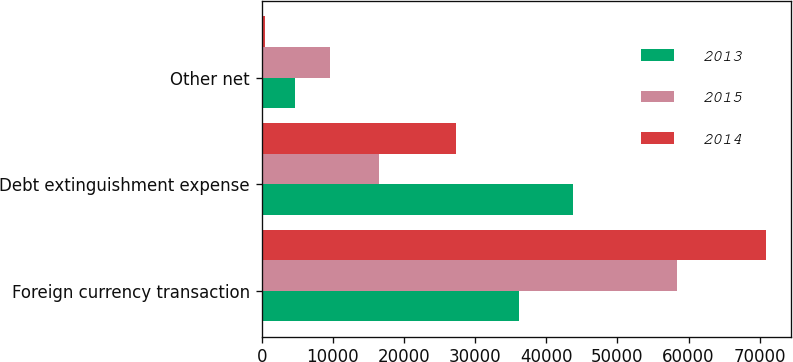Convert chart. <chart><loc_0><loc_0><loc_500><loc_500><stacked_bar_chart><ecel><fcel>Foreign currency transaction<fcel>Debt extinguishment expense<fcel>Other net<nl><fcel>2013<fcel>36201<fcel>43724<fcel>4723<nl><fcel>2015<fcel>58316<fcel>16495<fcel>9624<nl><fcel>2014<fcel>70851<fcel>27305<fcel>434<nl></chart> 